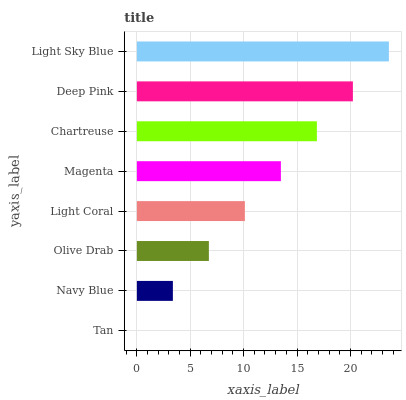Is Tan the minimum?
Answer yes or no. Yes. Is Light Sky Blue the maximum?
Answer yes or no. Yes. Is Navy Blue the minimum?
Answer yes or no. No. Is Navy Blue the maximum?
Answer yes or no. No. Is Navy Blue greater than Tan?
Answer yes or no. Yes. Is Tan less than Navy Blue?
Answer yes or no. Yes. Is Tan greater than Navy Blue?
Answer yes or no. No. Is Navy Blue less than Tan?
Answer yes or no. No. Is Magenta the high median?
Answer yes or no. Yes. Is Light Coral the low median?
Answer yes or no. Yes. Is Navy Blue the high median?
Answer yes or no. No. Is Navy Blue the low median?
Answer yes or no. No. 